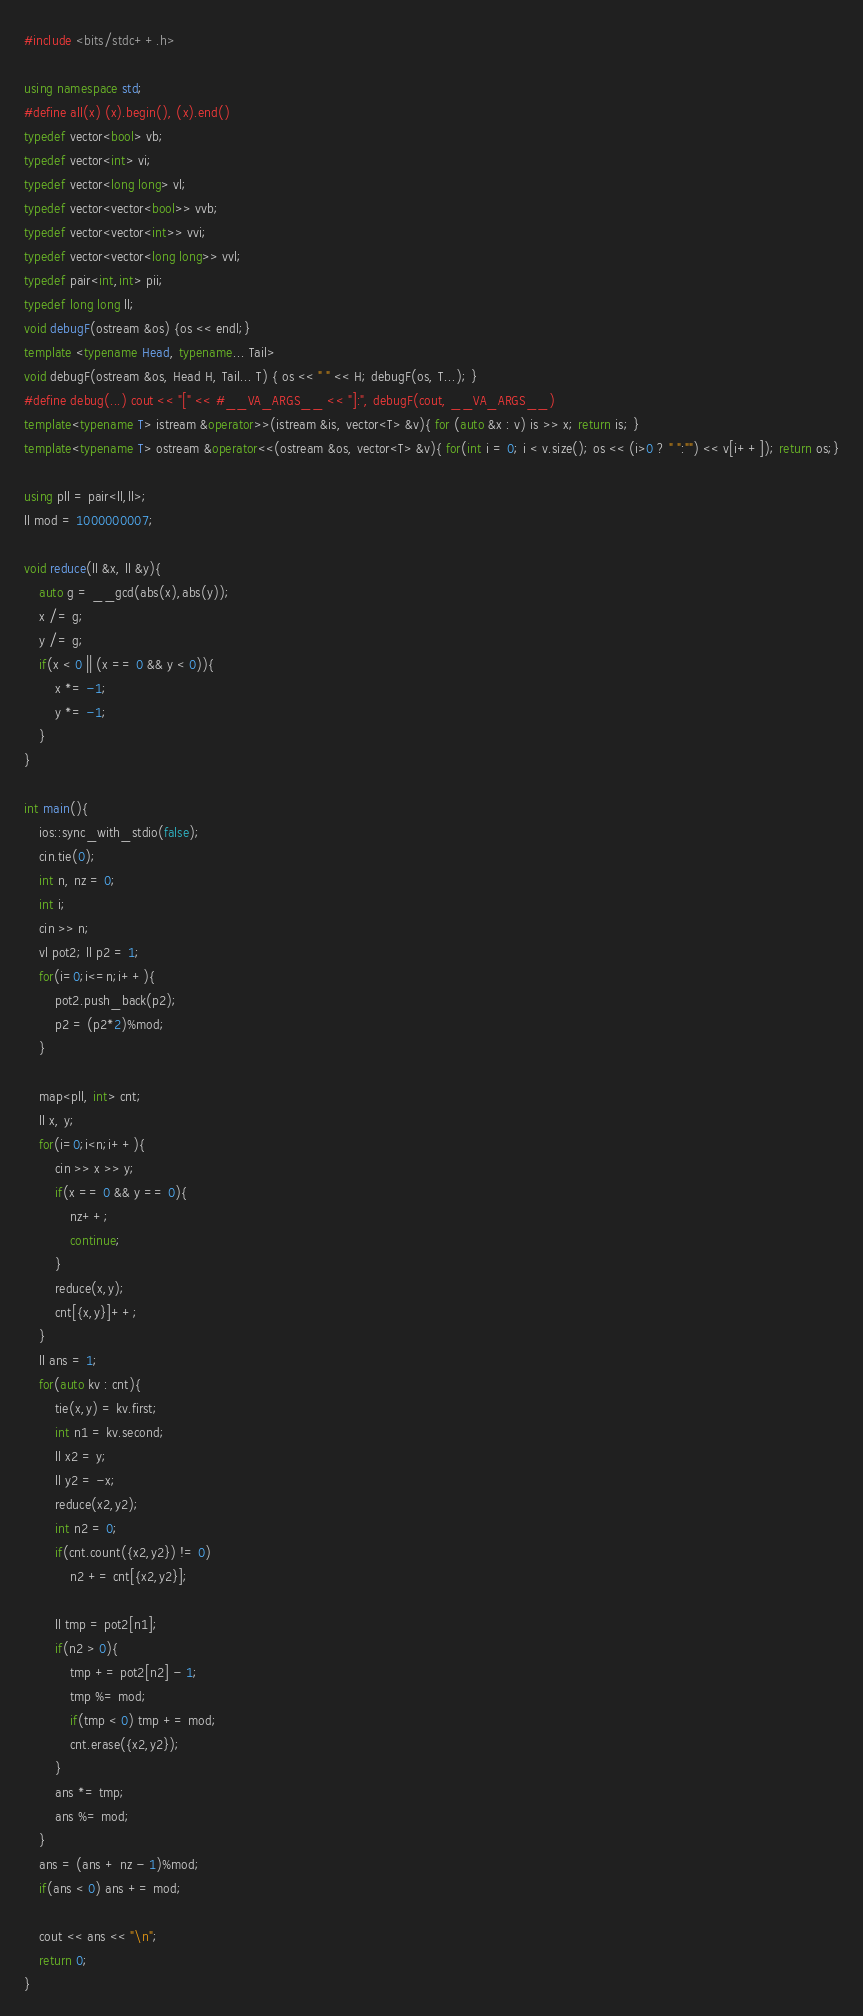Convert code to text. <code><loc_0><loc_0><loc_500><loc_500><_C++_>#include <bits/stdc++.h>

using namespace std;
#define all(x) (x).begin(), (x).end()
typedef vector<bool> vb;
typedef vector<int> vi;
typedef vector<long long> vl;
typedef vector<vector<bool>> vvb;
typedef vector<vector<int>> vvi;
typedef vector<vector<long long>> vvl;
typedef pair<int,int> pii;
typedef long long ll;
void debugF(ostream &os) {os << endl;}
template <typename Head, typename... Tail>
void debugF(ostream &os, Head H, Tail... T) { os << " " << H; debugF(os, T...); }
#define debug(...) cout << "[" << #__VA_ARGS__ << "]:", debugF(cout, __VA_ARGS__)
template<typename T> istream &operator>>(istream &is, vector<T> &v){ for (auto &x : v) is >> x; return is; }
template<typename T> ostream &operator<<(ostream &os, vector<T> &v){ for(int i = 0; i < v.size(); os << (i>0 ? " ":"") << v[i++]); return os;}

using pll = pair<ll,ll>;
ll mod = 1000000007;

void reduce(ll &x, ll &y){
    auto g = __gcd(abs(x),abs(y));
    x /= g;
    y /= g;
    if(x < 0 || (x == 0 && y < 0)){
        x *= -1;
        y *= -1;
    }
}

int main(){
    ios::sync_with_stdio(false);
    cin.tie(0);
    int n, nz = 0;
    int i;
    cin >> n;
    vl pot2; ll p2 = 1;
    for(i=0;i<=n;i++){
        pot2.push_back(p2);
        p2 = (p2*2)%mod;
    }

    map<pll, int> cnt;
    ll x, y;
    for(i=0;i<n;i++){
        cin >> x >> y;
        if(x == 0 && y == 0){
            nz++;
            continue;
        }
        reduce(x,y);
        cnt[{x,y}]++;
    }
    ll ans = 1;
    for(auto kv : cnt){
        tie(x,y) = kv.first;
        int n1 = kv.second;
        ll x2 = y;
        ll y2 = -x;
        reduce(x2,y2);
        int n2 = 0;
        if(cnt.count({x2,y2}) != 0)
            n2 += cnt[{x2,y2}];

        ll tmp = pot2[n1];
        if(n2 > 0){
            tmp += pot2[n2] - 1;
            tmp %= mod;
            if(tmp < 0) tmp += mod;
            cnt.erase({x2,y2});
        }
        ans *= tmp;
        ans %= mod;
    }
    ans = (ans + nz - 1)%mod;
    if(ans < 0) ans += mod;
    
    cout << ans << "\n";
    return 0;
}</code> 